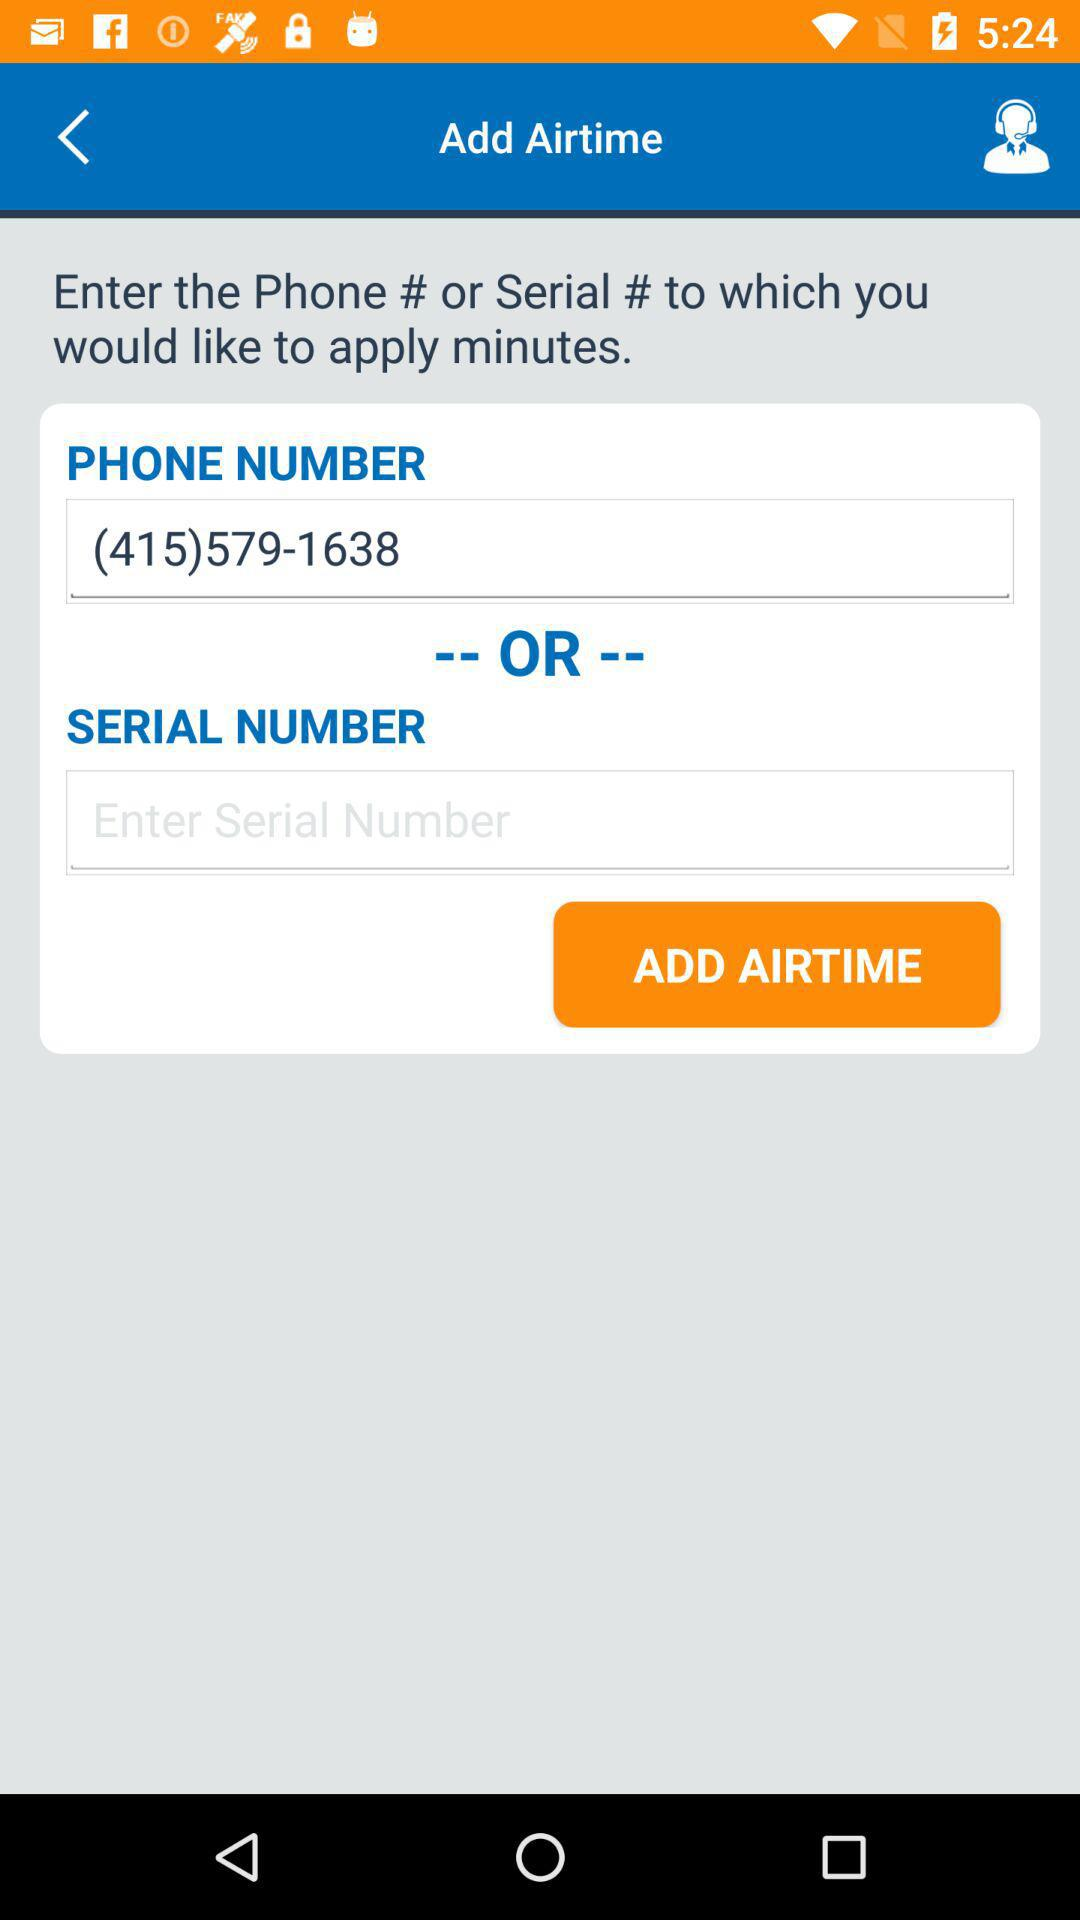What is the phone number? The phone number is (415) 579-1638. 